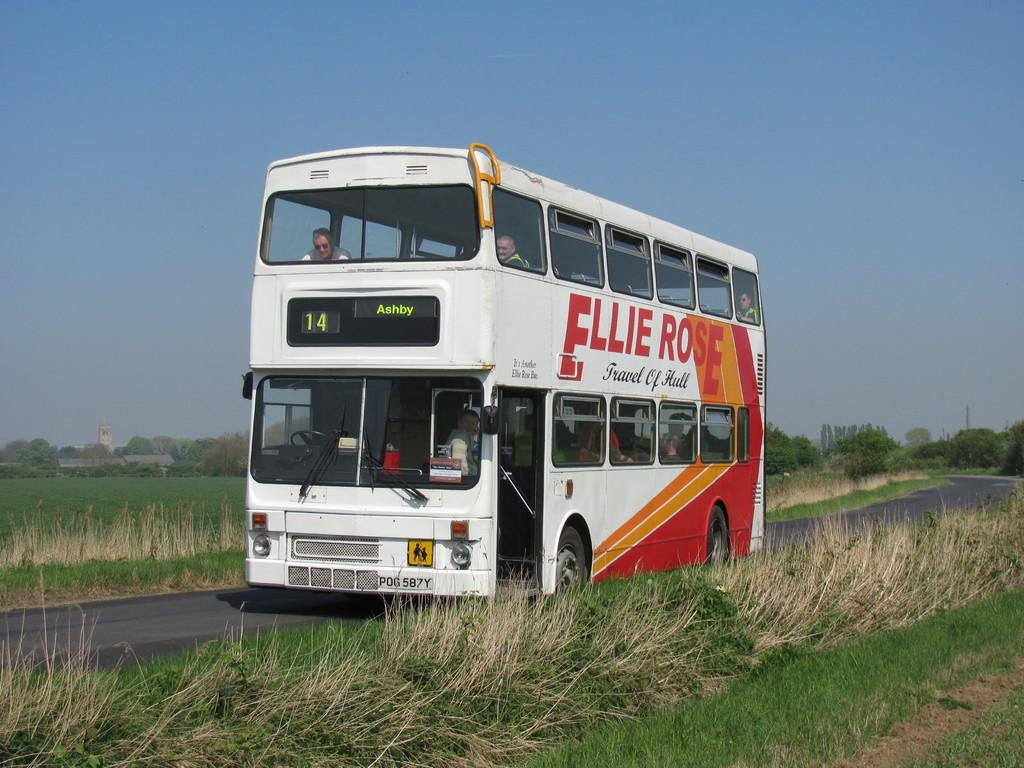What is the main subject of the image? The main subject of the image is a bus. Can you describe the colors of the bus? The bus has white, orange, and red colors. What type of vegetation can be seen in the image? There is green grass visible in the image. What is present on both sides of the image? There are trees on both sides of the image. What color is the sky in the image? The sky is blue in the image. Can you tell me how many beads are hanging from the scarecrow in the image? There is no scarecrow or beads present in the image; it features a bus with trees and grass in the background. What type of silk is draped over the bus in the image? There is no silk present in the image; the bus has white, orange, and red colors. 